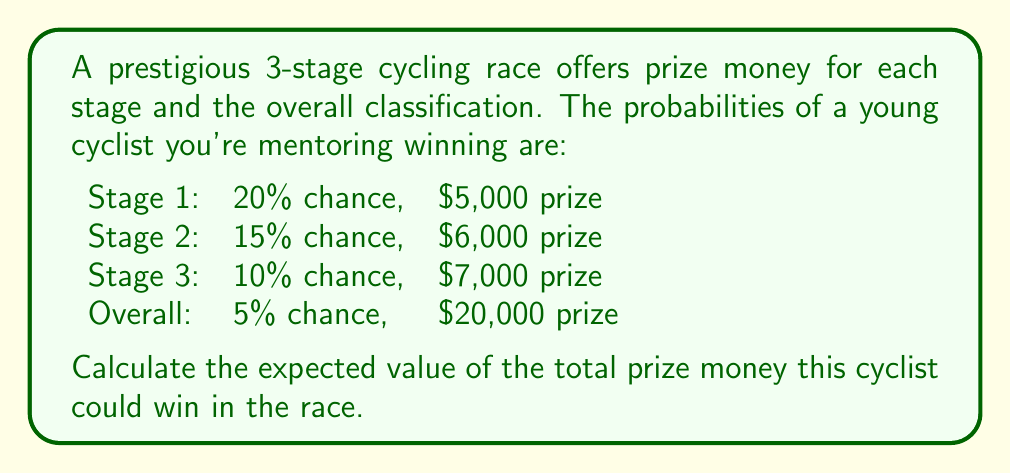Could you help me with this problem? To calculate the expected value, we need to multiply each prize amount by its probability of occurrence and then sum these values.

1. Stage 1:
   $E_1 = 0.20 \times \$5,000 = \$1,000$

2. Stage 2:
   $E_2 = 0.15 \times \$6,000 = \$900$

3. Stage 3:
   $E_3 = 0.10 \times \$7,000 = \$700$

4. Overall classification:
   $E_O = 0.05 \times \$20,000 = \$1,000$

5. Total expected value:
   $$E_{total} = E_1 + E_2 + E_3 + E_O$$
   $$E_{total} = \$1,000 + \$900 + \$700 + \$1,000 = \$3,600$$

Therefore, the expected value of the total prize money is $3,600.
Answer: $3,600 